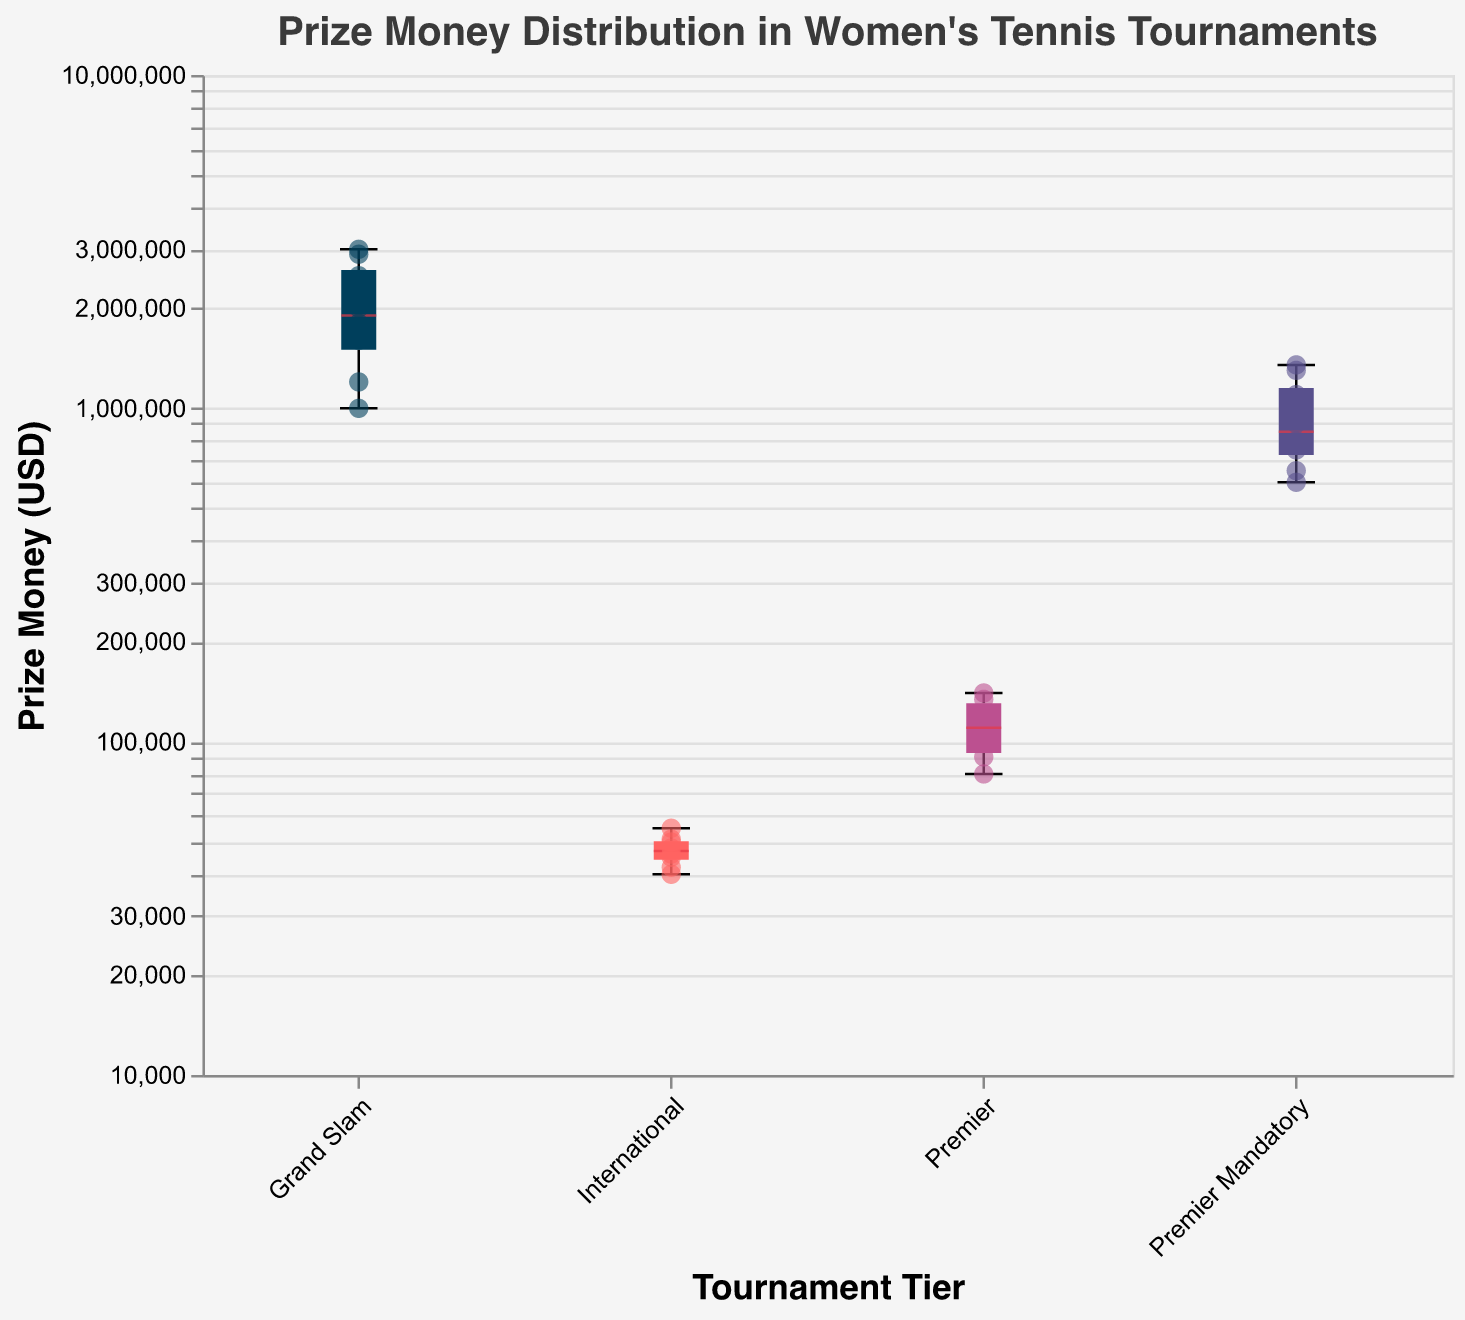What is the title of the figure? The title of the figure is usually displayed at the top of the plot. In this case, it states the overall purpose of the figure.
Answer: Prize Money Distribution in Women's Tennis Tournaments Which tournament tier has the highest median prize money? The median values for each tier are marked with a distinctive color on the box plots. From observation, Grand Slam has the highest marked median value.
Answer: Grand Slam What is the range of prize money in the International tier tournaments? The range is the difference between the maximum and minimum values in the International tier, as indicated by the endpoints of the whiskers in the box plot. The minimum is $40,000, and the maximum is $55,000.
Answer: $15,000 Which player earned the highest prize money and in which tournament? By looking at the highest point in the Grand Slam tier, the player tooltip indicates Ashleigh Barty at the US Open with $3,000,000.
Answer: Ashleigh Barty, US Open What is the average prize money for Premier tier tournaments? Calculate the average by summing the individual prize money amounts for Premier tier players and dividing by the number of entries: $(134,000 + 100,000 + 90,000 + 80,000 + 140,000 + 120,000) / 6 = $110,666.67
Answer: $110,666.67 Is the prize money distribution more varied in Grand Slam or Premier Mandatory tournaments? The variation can be judged by the length of the box and whiskers. Grand Slam shows a larger spread between minimum and maximum values compared to Premier Mandatory.
Answer: Grand Slam Which tournament tier has the largest number of players with prize money details? Count the number of data points (scatter points) in each tier. The Grand Slam tier shows more data points than the other tiers.
Answer: Grand Slam Compare the median prize money in Premier Mandatory to Premier tiers. Which is higher? From the boxplot, the median prize money for Premier Mandatory (marked in a unique color) is higher than that of the Premier tier.
Answer: Premier Mandatory What is the prize money for Naomi Osaka at the Indian Wells tournament? Look at the scatter point tooltip for Naomi Osaka in the Premier Mandatory tier at the Indian Wells tournament. It displays $1,350,000.
Answer: $1,350,000 